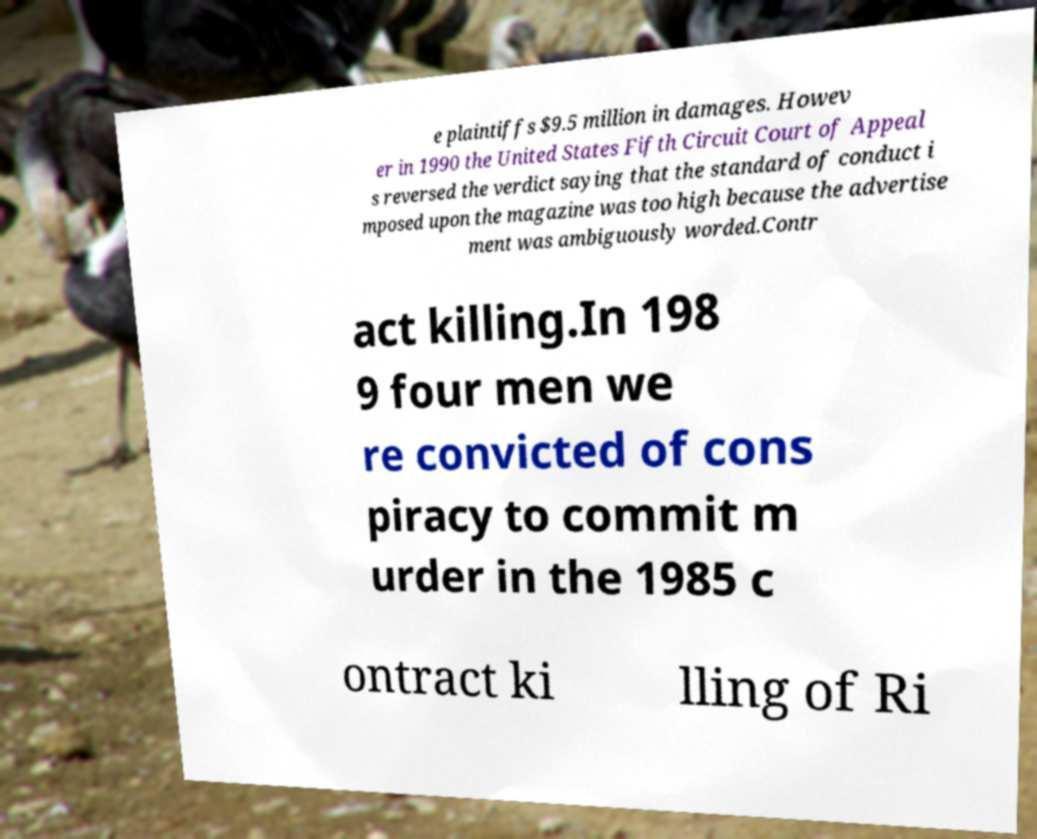Could you extract and type out the text from this image? e plaintiffs $9.5 million in damages. Howev er in 1990 the United States Fifth Circuit Court of Appeal s reversed the verdict saying that the standard of conduct i mposed upon the magazine was too high because the advertise ment was ambiguously worded.Contr act killing.In 198 9 four men we re convicted of cons piracy to commit m urder in the 1985 c ontract ki lling of Ri 